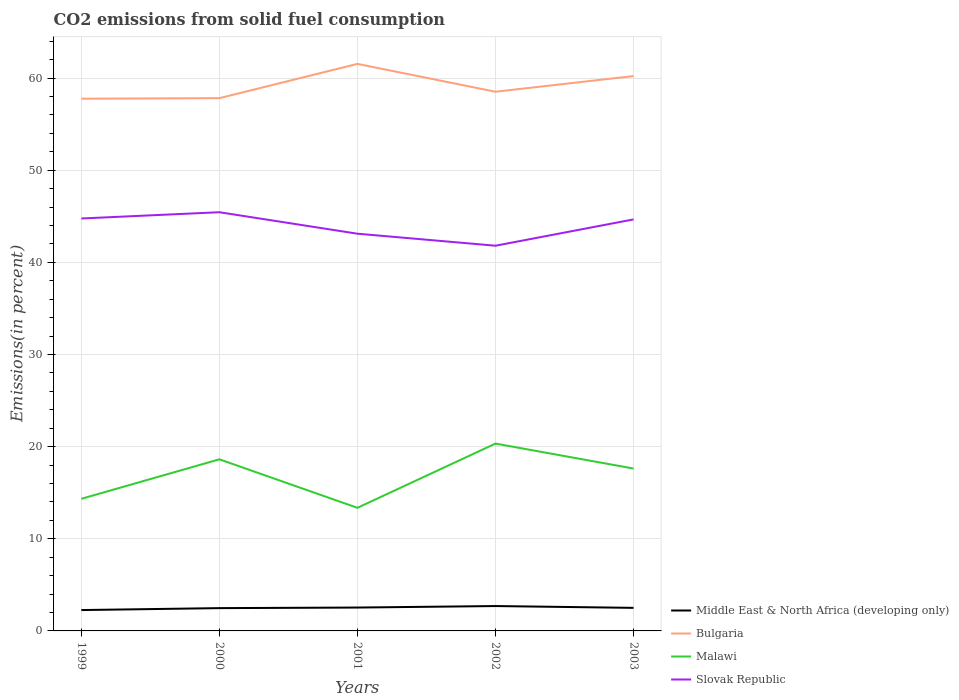How many different coloured lines are there?
Make the answer very short. 4. Is the number of lines equal to the number of legend labels?
Make the answer very short. Yes. Across all years, what is the maximum total CO2 emitted in Bulgaria?
Offer a very short reply. 57.76. What is the total total CO2 emitted in Middle East & North Africa (developing only) in the graph?
Give a very brief answer. -0.22. What is the difference between the highest and the second highest total CO2 emitted in Malawi?
Provide a short and direct response. 6.97. Does the graph contain grids?
Provide a short and direct response. Yes. How many legend labels are there?
Provide a short and direct response. 4. How are the legend labels stacked?
Give a very brief answer. Vertical. What is the title of the graph?
Keep it short and to the point. CO2 emissions from solid fuel consumption. What is the label or title of the Y-axis?
Provide a short and direct response. Emissions(in percent). What is the Emissions(in percent) of Middle East & North Africa (developing only) in 1999?
Your answer should be very brief. 2.26. What is the Emissions(in percent) in Bulgaria in 1999?
Your answer should be very brief. 57.76. What is the Emissions(in percent) in Malawi in 1999?
Make the answer very short. 14.34. What is the Emissions(in percent) in Slovak Republic in 1999?
Make the answer very short. 44.76. What is the Emissions(in percent) of Middle East & North Africa (developing only) in 2000?
Your answer should be compact. 2.47. What is the Emissions(in percent) in Bulgaria in 2000?
Provide a short and direct response. 57.82. What is the Emissions(in percent) of Malawi in 2000?
Your answer should be compact. 18.62. What is the Emissions(in percent) in Slovak Republic in 2000?
Offer a terse response. 45.44. What is the Emissions(in percent) in Middle East & North Africa (developing only) in 2001?
Keep it short and to the point. 2.54. What is the Emissions(in percent) in Bulgaria in 2001?
Offer a terse response. 61.54. What is the Emissions(in percent) in Malawi in 2001?
Provide a short and direct response. 13.36. What is the Emissions(in percent) of Slovak Republic in 2001?
Your response must be concise. 43.11. What is the Emissions(in percent) of Middle East & North Africa (developing only) in 2002?
Your answer should be very brief. 2.7. What is the Emissions(in percent) in Bulgaria in 2002?
Your answer should be very brief. 58.52. What is the Emissions(in percent) of Malawi in 2002?
Ensure brevity in your answer.  20.33. What is the Emissions(in percent) of Slovak Republic in 2002?
Your answer should be very brief. 41.81. What is the Emissions(in percent) in Middle East & North Africa (developing only) in 2003?
Your response must be concise. 2.5. What is the Emissions(in percent) in Bulgaria in 2003?
Give a very brief answer. 60.22. What is the Emissions(in percent) in Malawi in 2003?
Provide a short and direct response. 17.62. What is the Emissions(in percent) of Slovak Republic in 2003?
Ensure brevity in your answer.  44.66. Across all years, what is the maximum Emissions(in percent) in Middle East & North Africa (developing only)?
Your answer should be very brief. 2.7. Across all years, what is the maximum Emissions(in percent) of Bulgaria?
Offer a terse response. 61.54. Across all years, what is the maximum Emissions(in percent) in Malawi?
Your answer should be very brief. 20.33. Across all years, what is the maximum Emissions(in percent) of Slovak Republic?
Your response must be concise. 45.44. Across all years, what is the minimum Emissions(in percent) in Middle East & North Africa (developing only)?
Keep it short and to the point. 2.26. Across all years, what is the minimum Emissions(in percent) in Bulgaria?
Offer a very short reply. 57.76. Across all years, what is the minimum Emissions(in percent) of Malawi?
Keep it short and to the point. 13.36. Across all years, what is the minimum Emissions(in percent) in Slovak Republic?
Your answer should be compact. 41.81. What is the total Emissions(in percent) in Middle East & North Africa (developing only) in the graph?
Your answer should be very brief. 12.48. What is the total Emissions(in percent) of Bulgaria in the graph?
Keep it short and to the point. 295.86. What is the total Emissions(in percent) in Malawi in the graph?
Ensure brevity in your answer.  84.28. What is the total Emissions(in percent) in Slovak Republic in the graph?
Your answer should be very brief. 219.78. What is the difference between the Emissions(in percent) of Middle East & North Africa (developing only) in 1999 and that in 2000?
Make the answer very short. -0.21. What is the difference between the Emissions(in percent) in Bulgaria in 1999 and that in 2000?
Keep it short and to the point. -0.06. What is the difference between the Emissions(in percent) of Malawi in 1999 and that in 2000?
Offer a very short reply. -4.29. What is the difference between the Emissions(in percent) of Slovak Republic in 1999 and that in 2000?
Your answer should be compact. -0.68. What is the difference between the Emissions(in percent) in Middle East & North Africa (developing only) in 1999 and that in 2001?
Your answer should be compact. -0.27. What is the difference between the Emissions(in percent) of Bulgaria in 1999 and that in 2001?
Ensure brevity in your answer.  -3.78. What is the difference between the Emissions(in percent) of Malawi in 1999 and that in 2001?
Ensure brevity in your answer.  0.98. What is the difference between the Emissions(in percent) of Slovak Republic in 1999 and that in 2001?
Offer a terse response. 1.65. What is the difference between the Emissions(in percent) in Middle East & North Africa (developing only) in 1999 and that in 2002?
Your answer should be very brief. -0.44. What is the difference between the Emissions(in percent) in Bulgaria in 1999 and that in 2002?
Your response must be concise. -0.76. What is the difference between the Emissions(in percent) of Malawi in 1999 and that in 2002?
Give a very brief answer. -5.99. What is the difference between the Emissions(in percent) of Slovak Republic in 1999 and that in 2002?
Provide a succinct answer. 2.96. What is the difference between the Emissions(in percent) of Middle East & North Africa (developing only) in 1999 and that in 2003?
Your answer should be very brief. -0.24. What is the difference between the Emissions(in percent) of Bulgaria in 1999 and that in 2003?
Ensure brevity in your answer.  -2.46. What is the difference between the Emissions(in percent) in Malawi in 1999 and that in 2003?
Provide a succinct answer. -3.29. What is the difference between the Emissions(in percent) of Slovak Republic in 1999 and that in 2003?
Your response must be concise. 0.1. What is the difference between the Emissions(in percent) in Middle East & North Africa (developing only) in 2000 and that in 2001?
Provide a short and direct response. -0.06. What is the difference between the Emissions(in percent) of Bulgaria in 2000 and that in 2001?
Your answer should be very brief. -3.72. What is the difference between the Emissions(in percent) in Malawi in 2000 and that in 2001?
Offer a very short reply. 5.26. What is the difference between the Emissions(in percent) in Slovak Republic in 2000 and that in 2001?
Make the answer very short. 2.33. What is the difference between the Emissions(in percent) in Middle East & North Africa (developing only) in 2000 and that in 2002?
Your answer should be compact. -0.22. What is the difference between the Emissions(in percent) in Bulgaria in 2000 and that in 2002?
Keep it short and to the point. -0.7. What is the difference between the Emissions(in percent) in Malawi in 2000 and that in 2002?
Provide a succinct answer. -1.71. What is the difference between the Emissions(in percent) of Slovak Republic in 2000 and that in 2002?
Your answer should be very brief. 3.64. What is the difference between the Emissions(in percent) in Middle East & North Africa (developing only) in 2000 and that in 2003?
Your answer should be compact. -0.03. What is the difference between the Emissions(in percent) in Bulgaria in 2000 and that in 2003?
Keep it short and to the point. -2.4. What is the difference between the Emissions(in percent) in Slovak Republic in 2000 and that in 2003?
Keep it short and to the point. 0.78. What is the difference between the Emissions(in percent) of Middle East & North Africa (developing only) in 2001 and that in 2002?
Make the answer very short. -0.16. What is the difference between the Emissions(in percent) in Bulgaria in 2001 and that in 2002?
Your answer should be compact. 3.02. What is the difference between the Emissions(in percent) in Malawi in 2001 and that in 2002?
Give a very brief answer. -6.97. What is the difference between the Emissions(in percent) in Slovak Republic in 2001 and that in 2002?
Ensure brevity in your answer.  1.3. What is the difference between the Emissions(in percent) of Middle East & North Africa (developing only) in 2001 and that in 2003?
Keep it short and to the point. 0.03. What is the difference between the Emissions(in percent) of Bulgaria in 2001 and that in 2003?
Offer a very short reply. 1.32. What is the difference between the Emissions(in percent) of Malawi in 2001 and that in 2003?
Offer a terse response. -4.26. What is the difference between the Emissions(in percent) in Slovak Republic in 2001 and that in 2003?
Offer a very short reply. -1.55. What is the difference between the Emissions(in percent) of Middle East & North Africa (developing only) in 2002 and that in 2003?
Provide a short and direct response. 0.2. What is the difference between the Emissions(in percent) in Bulgaria in 2002 and that in 2003?
Provide a short and direct response. -1.7. What is the difference between the Emissions(in percent) in Malawi in 2002 and that in 2003?
Ensure brevity in your answer.  2.71. What is the difference between the Emissions(in percent) in Slovak Republic in 2002 and that in 2003?
Make the answer very short. -2.85. What is the difference between the Emissions(in percent) in Middle East & North Africa (developing only) in 1999 and the Emissions(in percent) in Bulgaria in 2000?
Your answer should be very brief. -55.56. What is the difference between the Emissions(in percent) in Middle East & North Africa (developing only) in 1999 and the Emissions(in percent) in Malawi in 2000?
Provide a short and direct response. -16.36. What is the difference between the Emissions(in percent) of Middle East & North Africa (developing only) in 1999 and the Emissions(in percent) of Slovak Republic in 2000?
Your response must be concise. -43.18. What is the difference between the Emissions(in percent) of Bulgaria in 1999 and the Emissions(in percent) of Malawi in 2000?
Ensure brevity in your answer.  39.14. What is the difference between the Emissions(in percent) in Bulgaria in 1999 and the Emissions(in percent) in Slovak Republic in 2000?
Offer a terse response. 12.32. What is the difference between the Emissions(in percent) of Malawi in 1999 and the Emissions(in percent) of Slovak Republic in 2000?
Make the answer very short. -31.1. What is the difference between the Emissions(in percent) in Middle East & North Africa (developing only) in 1999 and the Emissions(in percent) in Bulgaria in 2001?
Your answer should be compact. -59.28. What is the difference between the Emissions(in percent) of Middle East & North Africa (developing only) in 1999 and the Emissions(in percent) of Malawi in 2001?
Your response must be concise. -11.1. What is the difference between the Emissions(in percent) of Middle East & North Africa (developing only) in 1999 and the Emissions(in percent) of Slovak Republic in 2001?
Make the answer very short. -40.85. What is the difference between the Emissions(in percent) in Bulgaria in 1999 and the Emissions(in percent) in Malawi in 2001?
Keep it short and to the point. 44.4. What is the difference between the Emissions(in percent) in Bulgaria in 1999 and the Emissions(in percent) in Slovak Republic in 2001?
Offer a very short reply. 14.65. What is the difference between the Emissions(in percent) in Malawi in 1999 and the Emissions(in percent) in Slovak Republic in 2001?
Make the answer very short. -28.77. What is the difference between the Emissions(in percent) in Middle East & North Africa (developing only) in 1999 and the Emissions(in percent) in Bulgaria in 2002?
Ensure brevity in your answer.  -56.26. What is the difference between the Emissions(in percent) in Middle East & North Africa (developing only) in 1999 and the Emissions(in percent) in Malawi in 2002?
Provide a short and direct response. -18.07. What is the difference between the Emissions(in percent) of Middle East & North Africa (developing only) in 1999 and the Emissions(in percent) of Slovak Republic in 2002?
Give a very brief answer. -39.54. What is the difference between the Emissions(in percent) in Bulgaria in 1999 and the Emissions(in percent) in Malawi in 2002?
Your answer should be compact. 37.43. What is the difference between the Emissions(in percent) in Bulgaria in 1999 and the Emissions(in percent) in Slovak Republic in 2002?
Offer a terse response. 15.96. What is the difference between the Emissions(in percent) in Malawi in 1999 and the Emissions(in percent) in Slovak Republic in 2002?
Provide a short and direct response. -27.47. What is the difference between the Emissions(in percent) in Middle East & North Africa (developing only) in 1999 and the Emissions(in percent) in Bulgaria in 2003?
Your answer should be compact. -57.96. What is the difference between the Emissions(in percent) in Middle East & North Africa (developing only) in 1999 and the Emissions(in percent) in Malawi in 2003?
Give a very brief answer. -15.36. What is the difference between the Emissions(in percent) of Middle East & North Africa (developing only) in 1999 and the Emissions(in percent) of Slovak Republic in 2003?
Provide a succinct answer. -42.4. What is the difference between the Emissions(in percent) in Bulgaria in 1999 and the Emissions(in percent) in Malawi in 2003?
Your response must be concise. 40.14. What is the difference between the Emissions(in percent) in Bulgaria in 1999 and the Emissions(in percent) in Slovak Republic in 2003?
Your answer should be compact. 13.1. What is the difference between the Emissions(in percent) in Malawi in 1999 and the Emissions(in percent) in Slovak Republic in 2003?
Your answer should be very brief. -30.32. What is the difference between the Emissions(in percent) in Middle East & North Africa (developing only) in 2000 and the Emissions(in percent) in Bulgaria in 2001?
Provide a short and direct response. -59.07. What is the difference between the Emissions(in percent) of Middle East & North Africa (developing only) in 2000 and the Emissions(in percent) of Malawi in 2001?
Offer a terse response. -10.89. What is the difference between the Emissions(in percent) in Middle East & North Africa (developing only) in 2000 and the Emissions(in percent) in Slovak Republic in 2001?
Provide a short and direct response. -40.64. What is the difference between the Emissions(in percent) in Bulgaria in 2000 and the Emissions(in percent) in Malawi in 2001?
Your response must be concise. 44.46. What is the difference between the Emissions(in percent) in Bulgaria in 2000 and the Emissions(in percent) in Slovak Republic in 2001?
Ensure brevity in your answer.  14.71. What is the difference between the Emissions(in percent) in Malawi in 2000 and the Emissions(in percent) in Slovak Republic in 2001?
Give a very brief answer. -24.49. What is the difference between the Emissions(in percent) in Middle East & North Africa (developing only) in 2000 and the Emissions(in percent) in Bulgaria in 2002?
Keep it short and to the point. -56.05. What is the difference between the Emissions(in percent) in Middle East & North Africa (developing only) in 2000 and the Emissions(in percent) in Malawi in 2002?
Give a very brief answer. -17.86. What is the difference between the Emissions(in percent) in Middle East & North Africa (developing only) in 2000 and the Emissions(in percent) in Slovak Republic in 2002?
Keep it short and to the point. -39.33. What is the difference between the Emissions(in percent) in Bulgaria in 2000 and the Emissions(in percent) in Malawi in 2002?
Give a very brief answer. 37.49. What is the difference between the Emissions(in percent) in Bulgaria in 2000 and the Emissions(in percent) in Slovak Republic in 2002?
Your answer should be very brief. 16.01. What is the difference between the Emissions(in percent) of Malawi in 2000 and the Emissions(in percent) of Slovak Republic in 2002?
Provide a succinct answer. -23.18. What is the difference between the Emissions(in percent) of Middle East & North Africa (developing only) in 2000 and the Emissions(in percent) of Bulgaria in 2003?
Offer a very short reply. -57.75. What is the difference between the Emissions(in percent) in Middle East & North Africa (developing only) in 2000 and the Emissions(in percent) in Malawi in 2003?
Offer a terse response. -15.15. What is the difference between the Emissions(in percent) in Middle East & North Africa (developing only) in 2000 and the Emissions(in percent) in Slovak Republic in 2003?
Offer a very short reply. -42.19. What is the difference between the Emissions(in percent) in Bulgaria in 2000 and the Emissions(in percent) in Malawi in 2003?
Keep it short and to the point. 40.2. What is the difference between the Emissions(in percent) of Bulgaria in 2000 and the Emissions(in percent) of Slovak Republic in 2003?
Keep it short and to the point. 13.16. What is the difference between the Emissions(in percent) of Malawi in 2000 and the Emissions(in percent) of Slovak Republic in 2003?
Give a very brief answer. -26.04. What is the difference between the Emissions(in percent) of Middle East & North Africa (developing only) in 2001 and the Emissions(in percent) of Bulgaria in 2002?
Your answer should be very brief. -55.98. What is the difference between the Emissions(in percent) of Middle East & North Africa (developing only) in 2001 and the Emissions(in percent) of Malawi in 2002?
Your answer should be compact. -17.8. What is the difference between the Emissions(in percent) of Middle East & North Africa (developing only) in 2001 and the Emissions(in percent) of Slovak Republic in 2002?
Give a very brief answer. -39.27. What is the difference between the Emissions(in percent) of Bulgaria in 2001 and the Emissions(in percent) of Malawi in 2002?
Provide a short and direct response. 41.21. What is the difference between the Emissions(in percent) of Bulgaria in 2001 and the Emissions(in percent) of Slovak Republic in 2002?
Make the answer very short. 19.73. What is the difference between the Emissions(in percent) of Malawi in 2001 and the Emissions(in percent) of Slovak Republic in 2002?
Your response must be concise. -28.45. What is the difference between the Emissions(in percent) in Middle East & North Africa (developing only) in 2001 and the Emissions(in percent) in Bulgaria in 2003?
Keep it short and to the point. -57.68. What is the difference between the Emissions(in percent) in Middle East & North Africa (developing only) in 2001 and the Emissions(in percent) in Malawi in 2003?
Ensure brevity in your answer.  -15.09. What is the difference between the Emissions(in percent) in Middle East & North Africa (developing only) in 2001 and the Emissions(in percent) in Slovak Republic in 2003?
Your answer should be very brief. -42.12. What is the difference between the Emissions(in percent) in Bulgaria in 2001 and the Emissions(in percent) in Malawi in 2003?
Offer a very short reply. 43.92. What is the difference between the Emissions(in percent) of Bulgaria in 2001 and the Emissions(in percent) of Slovak Republic in 2003?
Offer a very short reply. 16.88. What is the difference between the Emissions(in percent) of Malawi in 2001 and the Emissions(in percent) of Slovak Republic in 2003?
Provide a short and direct response. -31.3. What is the difference between the Emissions(in percent) of Middle East & North Africa (developing only) in 2002 and the Emissions(in percent) of Bulgaria in 2003?
Provide a short and direct response. -57.52. What is the difference between the Emissions(in percent) in Middle East & North Africa (developing only) in 2002 and the Emissions(in percent) in Malawi in 2003?
Keep it short and to the point. -14.93. What is the difference between the Emissions(in percent) in Middle East & North Africa (developing only) in 2002 and the Emissions(in percent) in Slovak Republic in 2003?
Provide a succinct answer. -41.96. What is the difference between the Emissions(in percent) in Bulgaria in 2002 and the Emissions(in percent) in Malawi in 2003?
Offer a terse response. 40.9. What is the difference between the Emissions(in percent) in Bulgaria in 2002 and the Emissions(in percent) in Slovak Republic in 2003?
Offer a very short reply. 13.86. What is the difference between the Emissions(in percent) in Malawi in 2002 and the Emissions(in percent) in Slovak Republic in 2003?
Your answer should be very brief. -24.33. What is the average Emissions(in percent) of Middle East & North Africa (developing only) per year?
Ensure brevity in your answer.  2.5. What is the average Emissions(in percent) of Bulgaria per year?
Your response must be concise. 59.17. What is the average Emissions(in percent) of Malawi per year?
Provide a succinct answer. 16.86. What is the average Emissions(in percent) in Slovak Republic per year?
Provide a short and direct response. 43.96. In the year 1999, what is the difference between the Emissions(in percent) in Middle East & North Africa (developing only) and Emissions(in percent) in Bulgaria?
Your answer should be very brief. -55.5. In the year 1999, what is the difference between the Emissions(in percent) of Middle East & North Africa (developing only) and Emissions(in percent) of Malawi?
Your answer should be very brief. -12.08. In the year 1999, what is the difference between the Emissions(in percent) of Middle East & North Africa (developing only) and Emissions(in percent) of Slovak Republic?
Provide a short and direct response. -42.5. In the year 1999, what is the difference between the Emissions(in percent) in Bulgaria and Emissions(in percent) in Malawi?
Make the answer very short. 43.42. In the year 1999, what is the difference between the Emissions(in percent) of Bulgaria and Emissions(in percent) of Slovak Republic?
Keep it short and to the point. 13. In the year 1999, what is the difference between the Emissions(in percent) in Malawi and Emissions(in percent) in Slovak Republic?
Make the answer very short. -30.42. In the year 2000, what is the difference between the Emissions(in percent) of Middle East & North Africa (developing only) and Emissions(in percent) of Bulgaria?
Offer a very short reply. -55.35. In the year 2000, what is the difference between the Emissions(in percent) in Middle East & North Africa (developing only) and Emissions(in percent) in Malawi?
Your answer should be compact. -16.15. In the year 2000, what is the difference between the Emissions(in percent) in Middle East & North Africa (developing only) and Emissions(in percent) in Slovak Republic?
Ensure brevity in your answer.  -42.97. In the year 2000, what is the difference between the Emissions(in percent) in Bulgaria and Emissions(in percent) in Malawi?
Make the answer very short. 39.2. In the year 2000, what is the difference between the Emissions(in percent) of Bulgaria and Emissions(in percent) of Slovak Republic?
Offer a terse response. 12.38. In the year 2000, what is the difference between the Emissions(in percent) in Malawi and Emissions(in percent) in Slovak Republic?
Your answer should be very brief. -26.82. In the year 2001, what is the difference between the Emissions(in percent) in Middle East & North Africa (developing only) and Emissions(in percent) in Bulgaria?
Give a very brief answer. -59. In the year 2001, what is the difference between the Emissions(in percent) in Middle East & North Africa (developing only) and Emissions(in percent) in Malawi?
Your answer should be compact. -10.82. In the year 2001, what is the difference between the Emissions(in percent) in Middle East & North Africa (developing only) and Emissions(in percent) in Slovak Republic?
Your answer should be compact. -40.57. In the year 2001, what is the difference between the Emissions(in percent) of Bulgaria and Emissions(in percent) of Malawi?
Provide a succinct answer. 48.18. In the year 2001, what is the difference between the Emissions(in percent) in Bulgaria and Emissions(in percent) in Slovak Republic?
Give a very brief answer. 18.43. In the year 2001, what is the difference between the Emissions(in percent) of Malawi and Emissions(in percent) of Slovak Republic?
Your response must be concise. -29.75. In the year 2002, what is the difference between the Emissions(in percent) of Middle East & North Africa (developing only) and Emissions(in percent) of Bulgaria?
Offer a very short reply. -55.82. In the year 2002, what is the difference between the Emissions(in percent) in Middle East & North Africa (developing only) and Emissions(in percent) in Malawi?
Your answer should be compact. -17.63. In the year 2002, what is the difference between the Emissions(in percent) of Middle East & North Africa (developing only) and Emissions(in percent) of Slovak Republic?
Your response must be concise. -39.11. In the year 2002, what is the difference between the Emissions(in percent) in Bulgaria and Emissions(in percent) in Malawi?
Give a very brief answer. 38.19. In the year 2002, what is the difference between the Emissions(in percent) in Bulgaria and Emissions(in percent) in Slovak Republic?
Your answer should be very brief. 16.71. In the year 2002, what is the difference between the Emissions(in percent) of Malawi and Emissions(in percent) of Slovak Republic?
Provide a short and direct response. -21.47. In the year 2003, what is the difference between the Emissions(in percent) of Middle East & North Africa (developing only) and Emissions(in percent) of Bulgaria?
Provide a short and direct response. -57.72. In the year 2003, what is the difference between the Emissions(in percent) in Middle East & North Africa (developing only) and Emissions(in percent) in Malawi?
Make the answer very short. -15.12. In the year 2003, what is the difference between the Emissions(in percent) of Middle East & North Africa (developing only) and Emissions(in percent) of Slovak Republic?
Offer a very short reply. -42.16. In the year 2003, what is the difference between the Emissions(in percent) of Bulgaria and Emissions(in percent) of Malawi?
Provide a short and direct response. 42.6. In the year 2003, what is the difference between the Emissions(in percent) of Bulgaria and Emissions(in percent) of Slovak Republic?
Ensure brevity in your answer.  15.56. In the year 2003, what is the difference between the Emissions(in percent) in Malawi and Emissions(in percent) in Slovak Republic?
Your response must be concise. -27.04. What is the ratio of the Emissions(in percent) of Middle East & North Africa (developing only) in 1999 to that in 2000?
Give a very brief answer. 0.91. What is the ratio of the Emissions(in percent) of Malawi in 1999 to that in 2000?
Offer a terse response. 0.77. What is the ratio of the Emissions(in percent) of Slovak Republic in 1999 to that in 2000?
Offer a terse response. 0.98. What is the ratio of the Emissions(in percent) of Middle East & North Africa (developing only) in 1999 to that in 2001?
Provide a succinct answer. 0.89. What is the ratio of the Emissions(in percent) of Bulgaria in 1999 to that in 2001?
Make the answer very short. 0.94. What is the ratio of the Emissions(in percent) of Malawi in 1999 to that in 2001?
Ensure brevity in your answer.  1.07. What is the ratio of the Emissions(in percent) of Slovak Republic in 1999 to that in 2001?
Provide a short and direct response. 1.04. What is the ratio of the Emissions(in percent) in Middle East & North Africa (developing only) in 1999 to that in 2002?
Offer a terse response. 0.84. What is the ratio of the Emissions(in percent) of Bulgaria in 1999 to that in 2002?
Offer a terse response. 0.99. What is the ratio of the Emissions(in percent) in Malawi in 1999 to that in 2002?
Offer a terse response. 0.71. What is the ratio of the Emissions(in percent) of Slovak Republic in 1999 to that in 2002?
Make the answer very short. 1.07. What is the ratio of the Emissions(in percent) of Middle East & North Africa (developing only) in 1999 to that in 2003?
Offer a very short reply. 0.9. What is the ratio of the Emissions(in percent) in Bulgaria in 1999 to that in 2003?
Give a very brief answer. 0.96. What is the ratio of the Emissions(in percent) in Malawi in 1999 to that in 2003?
Make the answer very short. 0.81. What is the ratio of the Emissions(in percent) in Middle East & North Africa (developing only) in 2000 to that in 2001?
Make the answer very short. 0.98. What is the ratio of the Emissions(in percent) of Bulgaria in 2000 to that in 2001?
Provide a short and direct response. 0.94. What is the ratio of the Emissions(in percent) of Malawi in 2000 to that in 2001?
Your answer should be very brief. 1.39. What is the ratio of the Emissions(in percent) in Slovak Republic in 2000 to that in 2001?
Your answer should be compact. 1.05. What is the ratio of the Emissions(in percent) in Middle East & North Africa (developing only) in 2000 to that in 2002?
Keep it short and to the point. 0.92. What is the ratio of the Emissions(in percent) of Malawi in 2000 to that in 2002?
Your answer should be compact. 0.92. What is the ratio of the Emissions(in percent) in Slovak Republic in 2000 to that in 2002?
Give a very brief answer. 1.09. What is the ratio of the Emissions(in percent) in Bulgaria in 2000 to that in 2003?
Make the answer very short. 0.96. What is the ratio of the Emissions(in percent) of Malawi in 2000 to that in 2003?
Give a very brief answer. 1.06. What is the ratio of the Emissions(in percent) in Slovak Republic in 2000 to that in 2003?
Provide a short and direct response. 1.02. What is the ratio of the Emissions(in percent) of Middle East & North Africa (developing only) in 2001 to that in 2002?
Your answer should be compact. 0.94. What is the ratio of the Emissions(in percent) in Bulgaria in 2001 to that in 2002?
Make the answer very short. 1.05. What is the ratio of the Emissions(in percent) in Malawi in 2001 to that in 2002?
Give a very brief answer. 0.66. What is the ratio of the Emissions(in percent) of Slovak Republic in 2001 to that in 2002?
Your response must be concise. 1.03. What is the ratio of the Emissions(in percent) in Middle East & North Africa (developing only) in 2001 to that in 2003?
Offer a very short reply. 1.01. What is the ratio of the Emissions(in percent) in Bulgaria in 2001 to that in 2003?
Provide a short and direct response. 1.02. What is the ratio of the Emissions(in percent) of Malawi in 2001 to that in 2003?
Offer a very short reply. 0.76. What is the ratio of the Emissions(in percent) of Slovak Republic in 2001 to that in 2003?
Offer a very short reply. 0.97. What is the ratio of the Emissions(in percent) of Middle East & North Africa (developing only) in 2002 to that in 2003?
Your answer should be very brief. 1.08. What is the ratio of the Emissions(in percent) in Bulgaria in 2002 to that in 2003?
Ensure brevity in your answer.  0.97. What is the ratio of the Emissions(in percent) of Malawi in 2002 to that in 2003?
Offer a terse response. 1.15. What is the ratio of the Emissions(in percent) of Slovak Republic in 2002 to that in 2003?
Provide a succinct answer. 0.94. What is the difference between the highest and the second highest Emissions(in percent) in Middle East & North Africa (developing only)?
Ensure brevity in your answer.  0.16. What is the difference between the highest and the second highest Emissions(in percent) in Bulgaria?
Offer a terse response. 1.32. What is the difference between the highest and the second highest Emissions(in percent) in Malawi?
Provide a short and direct response. 1.71. What is the difference between the highest and the second highest Emissions(in percent) in Slovak Republic?
Keep it short and to the point. 0.68. What is the difference between the highest and the lowest Emissions(in percent) of Middle East & North Africa (developing only)?
Offer a terse response. 0.44. What is the difference between the highest and the lowest Emissions(in percent) in Bulgaria?
Your response must be concise. 3.78. What is the difference between the highest and the lowest Emissions(in percent) of Malawi?
Your answer should be very brief. 6.97. What is the difference between the highest and the lowest Emissions(in percent) in Slovak Republic?
Make the answer very short. 3.64. 